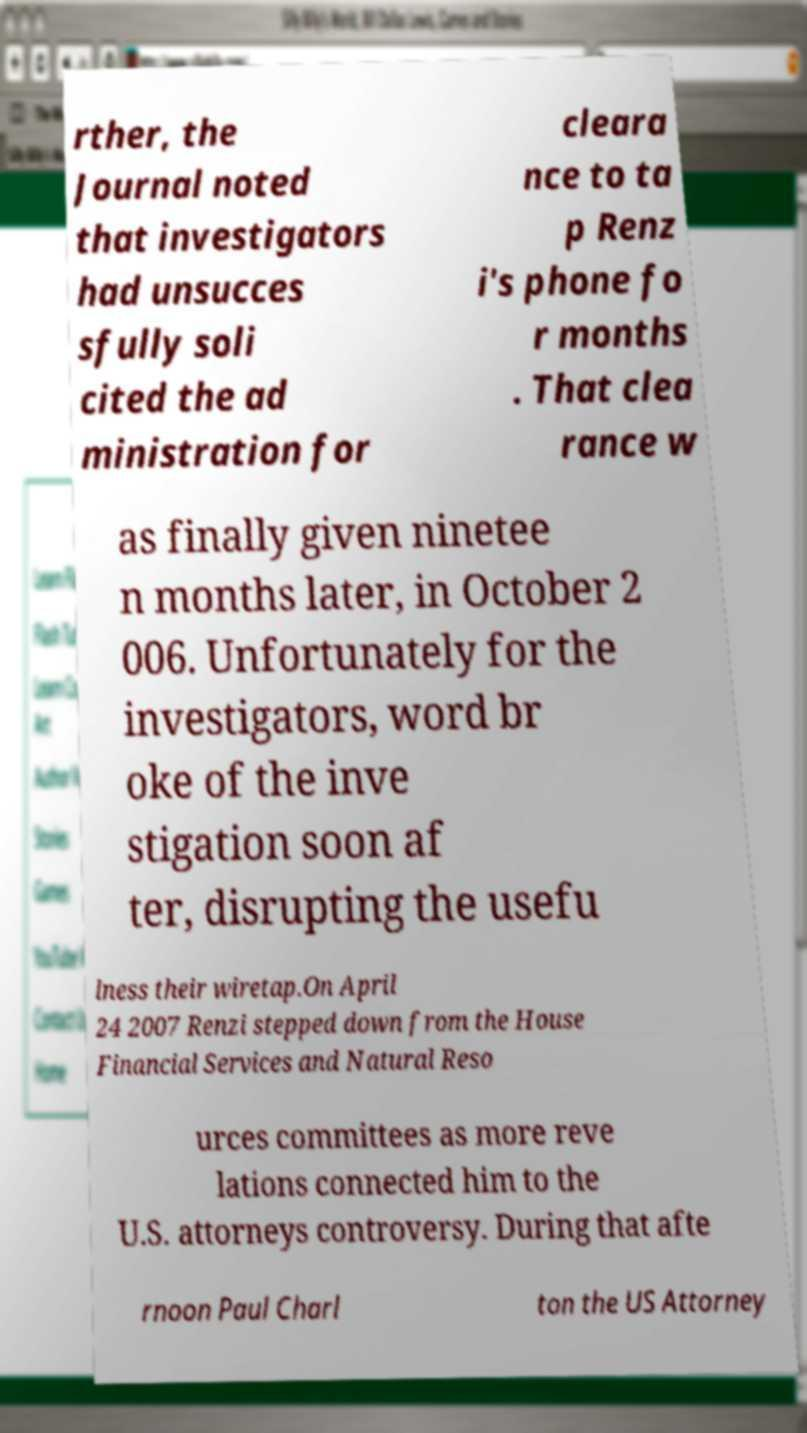Can you accurately transcribe the text from the provided image for me? rther, the Journal noted that investigators had unsucces sfully soli cited the ad ministration for cleara nce to ta p Renz i's phone fo r months . That clea rance w as finally given ninetee n months later, in October 2 006. Unfortunately for the investigators, word br oke of the inve stigation soon af ter, disrupting the usefu lness their wiretap.On April 24 2007 Renzi stepped down from the House Financial Services and Natural Reso urces committees as more reve lations connected him to the U.S. attorneys controversy. During that afte rnoon Paul Charl ton the US Attorney 